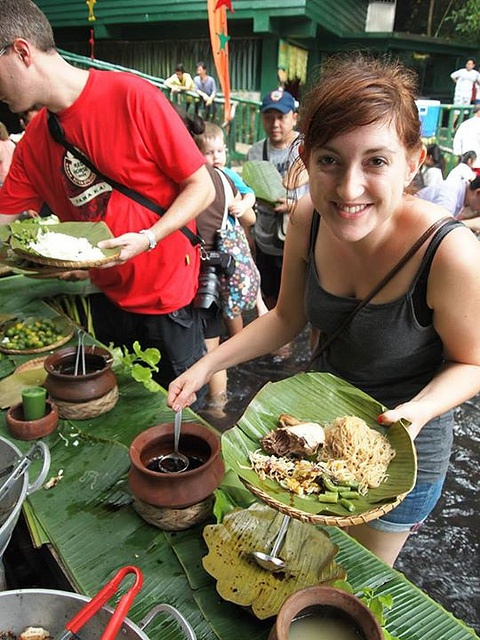Describe the objects in this image and their specific colors. I can see people in gray, black, brown, and ivory tones, people in black, red, brown, and maroon tones, bowl in gray, black, maroon, and brown tones, people in gray, black, darkgray, and lightgray tones, and bowl in gray, black, and tan tones in this image. 